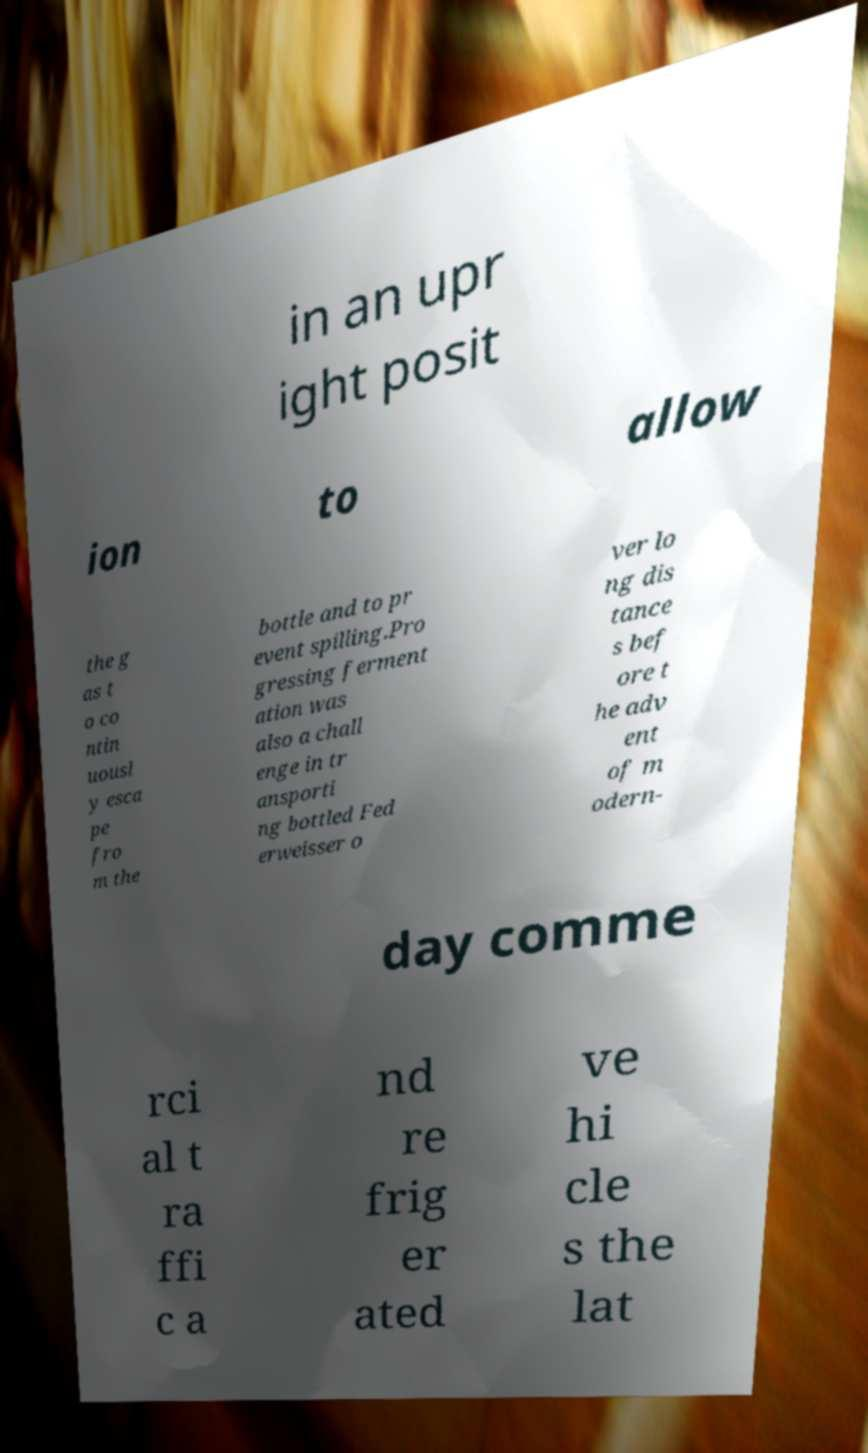Can you accurately transcribe the text from the provided image for me? in an upr ight posit ion to allow the g as t o co ntin uousl y esca pe fro m the bottle and to pr event spilling.Pro gressing ferment ation was also a chall enge in tr ansporti ng bottled Fed erweisser o ver lo ng dis tance s bef ore t he adv ent of m odern- day comme rci al t ra ffi c a nd re frig er ated ve hi cle s the lat 